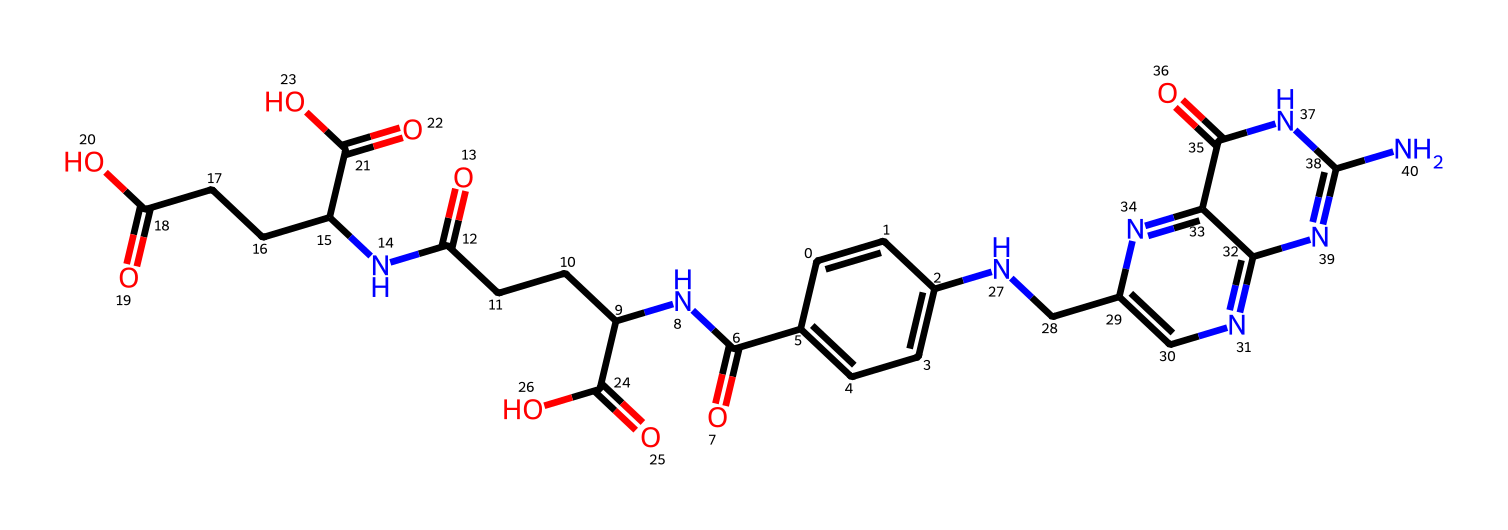What is the name of this chemical? The chemical structure provided corresponds to folate, which is a B-vitamin essential for DNA synthesis and repair, recognized by its unique functional groups and nitrogenous base.
Answer: folate How many nitrogen atoms are in the structure? By examining the SMILES representation, we can identify the nitrogen atoms, which are present in the ring structures and the functional groups. There are five nitrogen atoms in total in the folate structure.
Answer: five How many carboxylic acid groups are in this structure? The presence of carboxylic acid groups can be determined by looking for the -COOH functional group in the structure. In this case, there are three distinctly identifiable carboxylic acid groups in the folate structure.
Answer: three What kind of bonds are predominantly present in this structure? Analyzing the SMILES notation reveals numerous carbon-carbon and carbon-nitrogen single bonds, as well as double bonds between carbon and oxygen, primarily indicating the type of bonds in folate.
Answer: single and double bonds What role does this molecule play in the human body? Folate plays a critical role in DNA synthesis, repair, and cell division, as indicated by its importance in biochemical processes and the presence of essential functional groups for such activities.
Answer: DNA synthesis and repair 